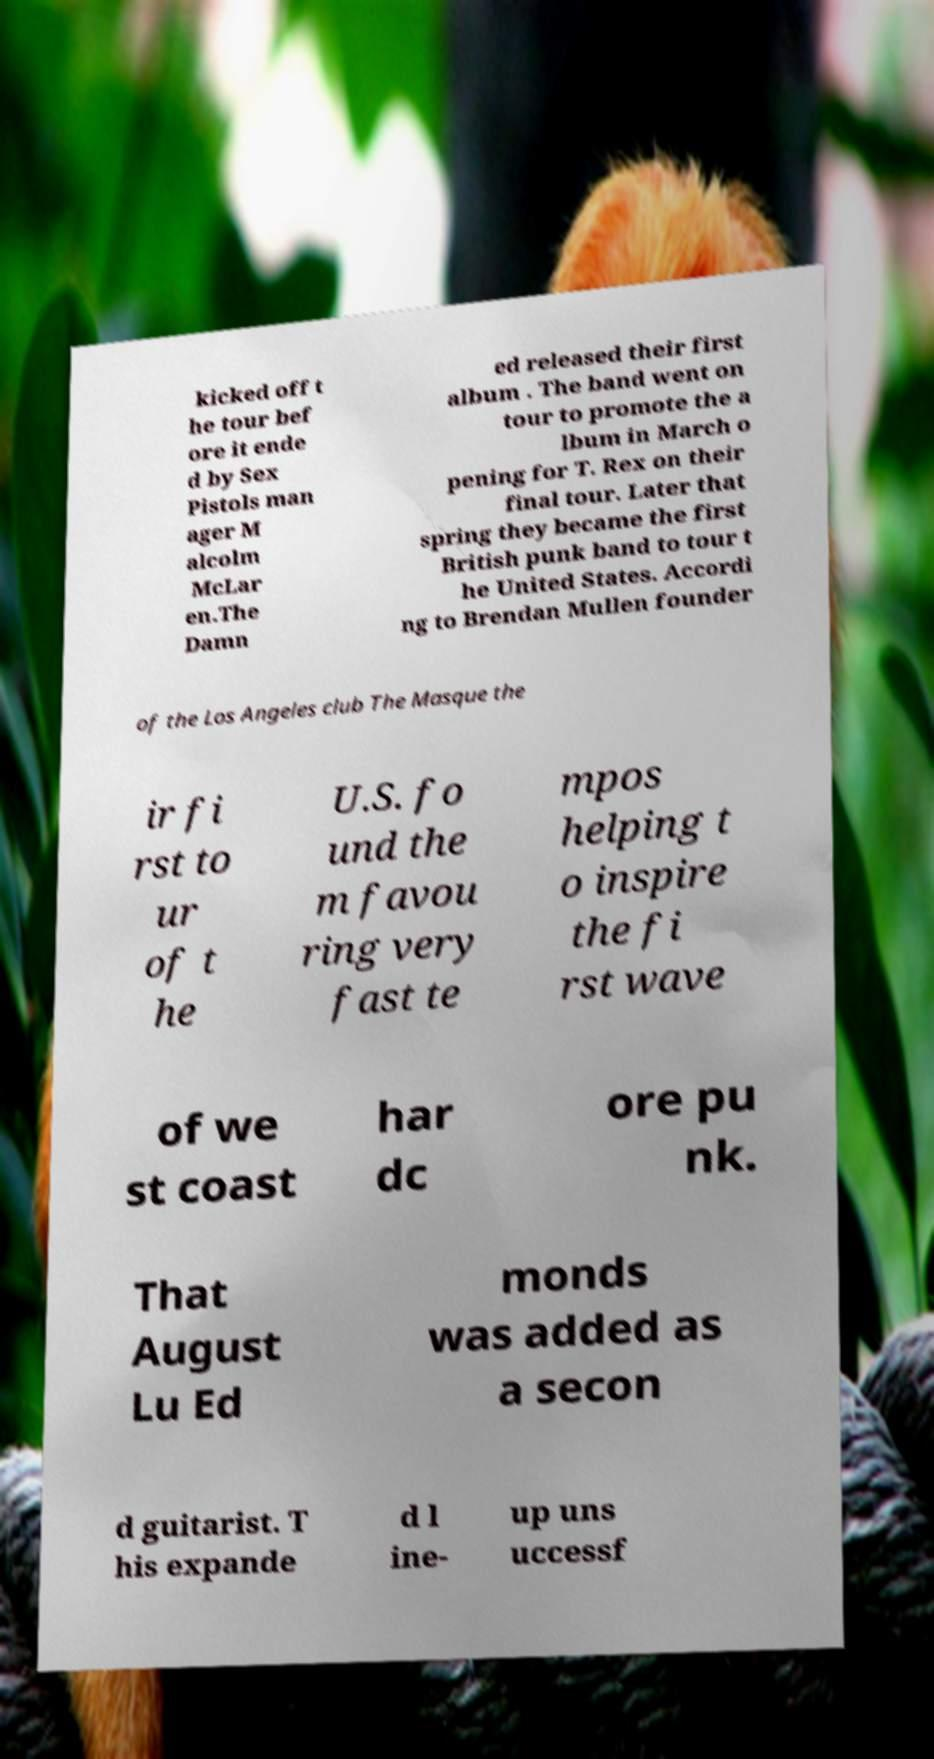What messages or text are displayed in this image? I need them in a readable, typed format. kicked off t he tour bef ore it ende d by Sex Pistols man ager M alcolm McLar en.The Damn ed released their first album . The band went on tour to promote the a lbum in March o pening for T. Rex on their final tour. Later that spring they became the first British punk band to tour t he United States. Accordi ng to Brendan Mullen founder of the Los Angeles club The Masque the ir fi rst to ur of t he U.S. fo und the m favou ring very fast te mpos helping t o inspire the fi rst wave of we st coast har dc ore pu nk. That August Lu Ed monds was added as a secon d guitarist. T his expande d l ine- up uns uccessf 